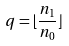<formula> <loc_0><loc_0><loc_500><loc_500>q = \lfloor \frac { n _ { 1 } } { n _ { 0 } } \rfloor</formula> 